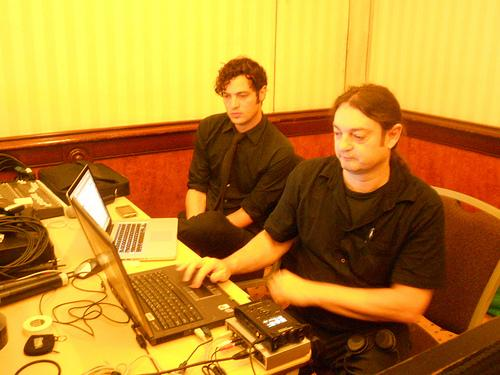Mention the type of furniture next to which an object can be found, and the object itself. A chair is next to a desk where a laptop and laptop bag are placed. What is the primary action being performed by the man in the image, and what is he looking at? The man is sitting at the desk, looking at a laptop. Point out distinct features of the man's hairstyle. The man has curly and long hair, and noticeable sideburns. Describe the various objects found on the desk, and the color(s) of each object. A black laptop is on the desk, along with a black laptop bag, and a black cellphone. List the objects associated with the captions "the wall has stripes" and "coin purse is black." A yellow wall with stripes, and multiple black coin purses. Describe the appearance of the man's attire and the location of the headphone. The man is wearing a black shirt and tie with a pen in his pocket, and he also has headphones around his neck. State the color of the wall and describe its pattern. The wall is yellow and has a striped pattern. What are the types of clothing the man is wearing and the features of his appearance? The man is wearing a black shirt and tie with curly hair, sideburns, and long hair. Briefly mention the objects found on the desk and their respective colors. A black laptop, a black laptop bag, and a black cellphone are on the desk. Identify the color and state (on or off) of the laptop, and its location. The laptop is black, turned on, and located on a desk. 